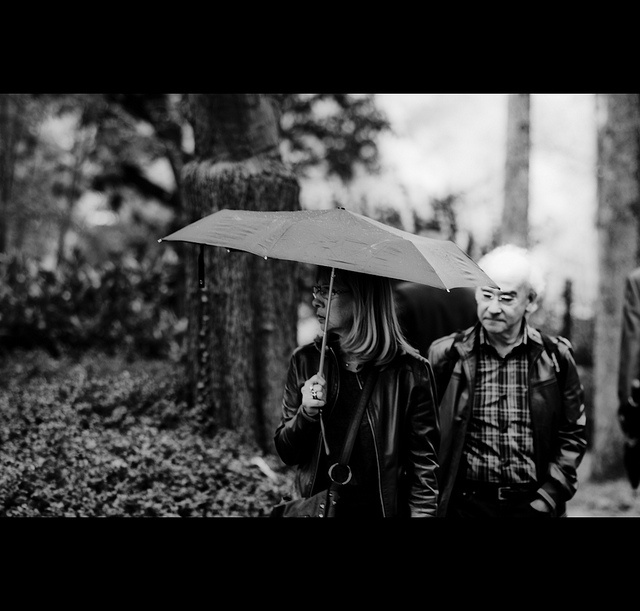Describe the objects in this image and their specific colors. I can see people in black, gray, darkgray, and lightgray tones, people in black, gray, darkgray, and lightgray tones, umbrella in black, darkgray, gray, and lightgray tones, and handbag in black, gray, darkgray, and lightgray tones in this image. 